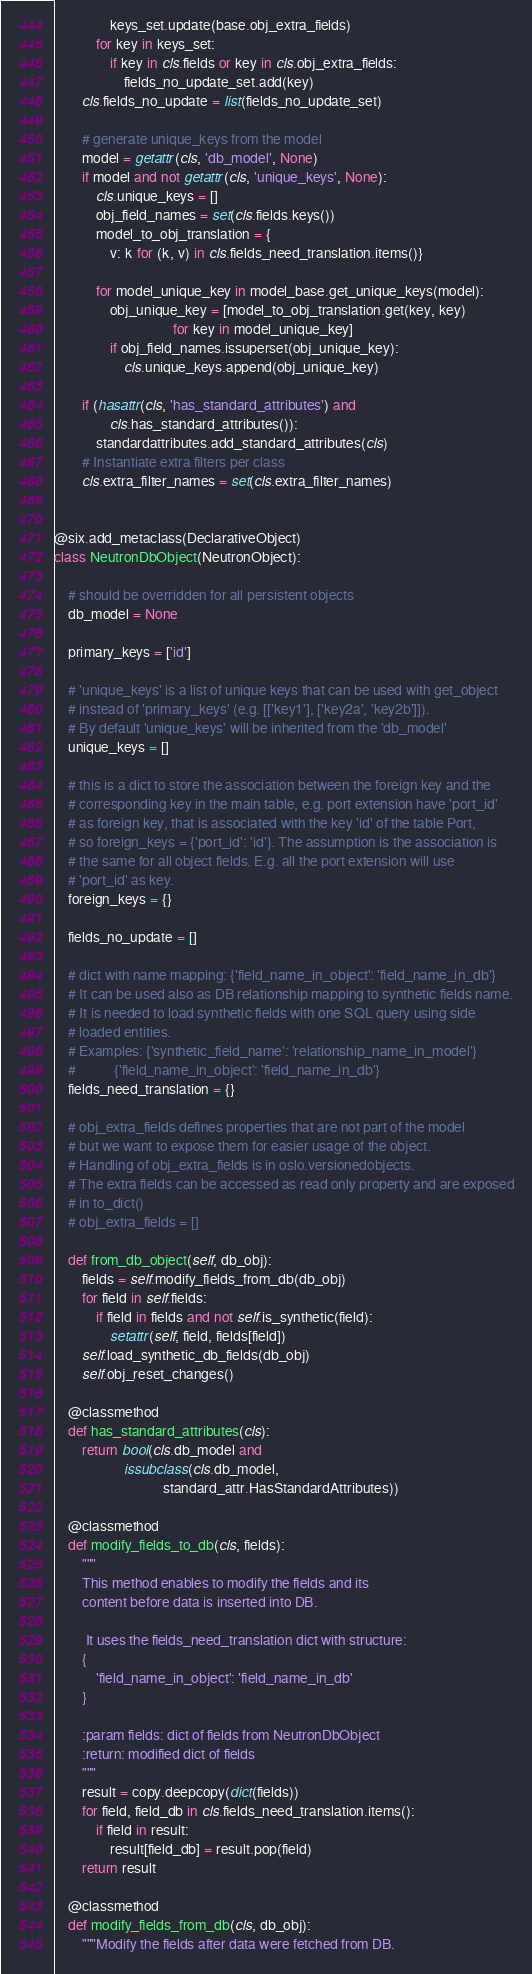Convert code to text. <code><loc_0><loc_0><loc_500><loc_500><_Python_>                keys_set.update(base.obj_extra_fields)
            for key in keys_set:
                if key in cls.fields or key in cls.obj_extra_fields:
                    fields_no_update_set.add(key)
        cls.fields_no_update = list(fields_no_update_set)

        # generate unique_keys from the model
        model = getattr(cls, 'db_model', None)
        if model and not getattr(cls, 'unique_keys', None):
            cls.unique_keys = []
            obj_field_names = set(cls.fields.keys())
            model_to_obj_translation = {
                v: k for (k, v) in cls.fields_need_translation.items()}

            for model_unique_key in model_base.get_unique_keys(model):
                obj_unique_key = [model_to_obj_translation.get(key, key)
                                  for key in model_unique_key]
                if obj_field_names.issuperset(obj_unique_key):
                    cls.unique_keys.append(obj_unique_key)

        if (hasattr(cls, 'has_standard_attributes') and
                cls.has_standard_attributes()):
            standardattributes.add_standard_attributes(cls)
        # Instantiate extra filters per class
        cls.extra_filter_names = set(cls.extra_filter_names)


@six.add_metaclass(DeclarativeObject)
class NeutronDbObject(NeutronObject):

    # should be overridden for all persistent objects
    db_model = None

    primary_keys = ['id']

    # 'unique_keys' is a list of unique keys that can be used with get_object
    # instead of 'primary_keys' (e.g. [['key1'], ['key2a', 'key2b']]).
    # By default 'unique_keys' will be inherited from the 'db_model'
    unique_keys = []

    # this is a dict to store the association between the foreign key and the
    # corresponding key in the main table, e.g. port extension have 'port_id'
    # as foreign key, that is associated with the key 'id' of the table Port,
    # so foreign_keys = {'port_id': 'id'}. The assumption is the association is
    # the same for all object fields. E.g. all the port extension will use
    # 'port_id' as key.
    foreign_keys = {}

    fields_no_update = []

    # dict with name mapping: {'field_name_in_object': 'field_name_in_db'}
    # It can be used also as DB relationship mapping to synthetic fields name.
    # It is needed to load synthetic fields with one SQL query using side
    # loaded entities.
    # Examples: {'synthetic_field_name': 'relationship_name_in_model'}
    #           {'field_name_in_object': 'field_name_in_db'}
    fields_need_translation = {}

    # obj_extra_fields defines properties that are not part of the model
    # but we want to expose them for easier usage of the object.
    # Handling of obj_extra_fields is in oslo.versionedobjects.
    # The extra fields can be accessed as read only property and are exposed
    # in to_dict()
    # obj_extra_fields = []

    def from_db_object(self, db_obj):
        fields = self.modify_fields_from_db(db_obj)
        for field in self.fields:
            if field in fields and not self.is_synthetic(field):
                setattr(self, field, fields[field])
        self.load_synthetic_db_fields(db_obj)
        self.obj_reset_changes()

    @classmethod
    def has_standard_attributes(cls):
        return bool(cls.db_model and
                    issubclass(cls.db_model,
                               standard_attr.HasStandardAttributes))

    @classmethod
    def modify_fields_to_db(cls, fields):
        """
        This method enables to modify the fields and its
        content before data is inserted into DB.

         It uses the fields_need_translation dict with structure:
        {
            'field_name_in_object': 'field_name_in_db'
        }

        :param fields: dict of fields from NeutronDbObject
        :return: modified dict of fields
        """
        result = copy.deepcopy(dict(fields))
        for field, field_db in cls.fields_need_translation.items():
            if field in result:
                result[field_db] = result.pop(field)
        return result

    @classmethod
    def modify_fields_from_db(cls, db_obj):
        """Modify the fields after data were fetched from DB.
</code> 